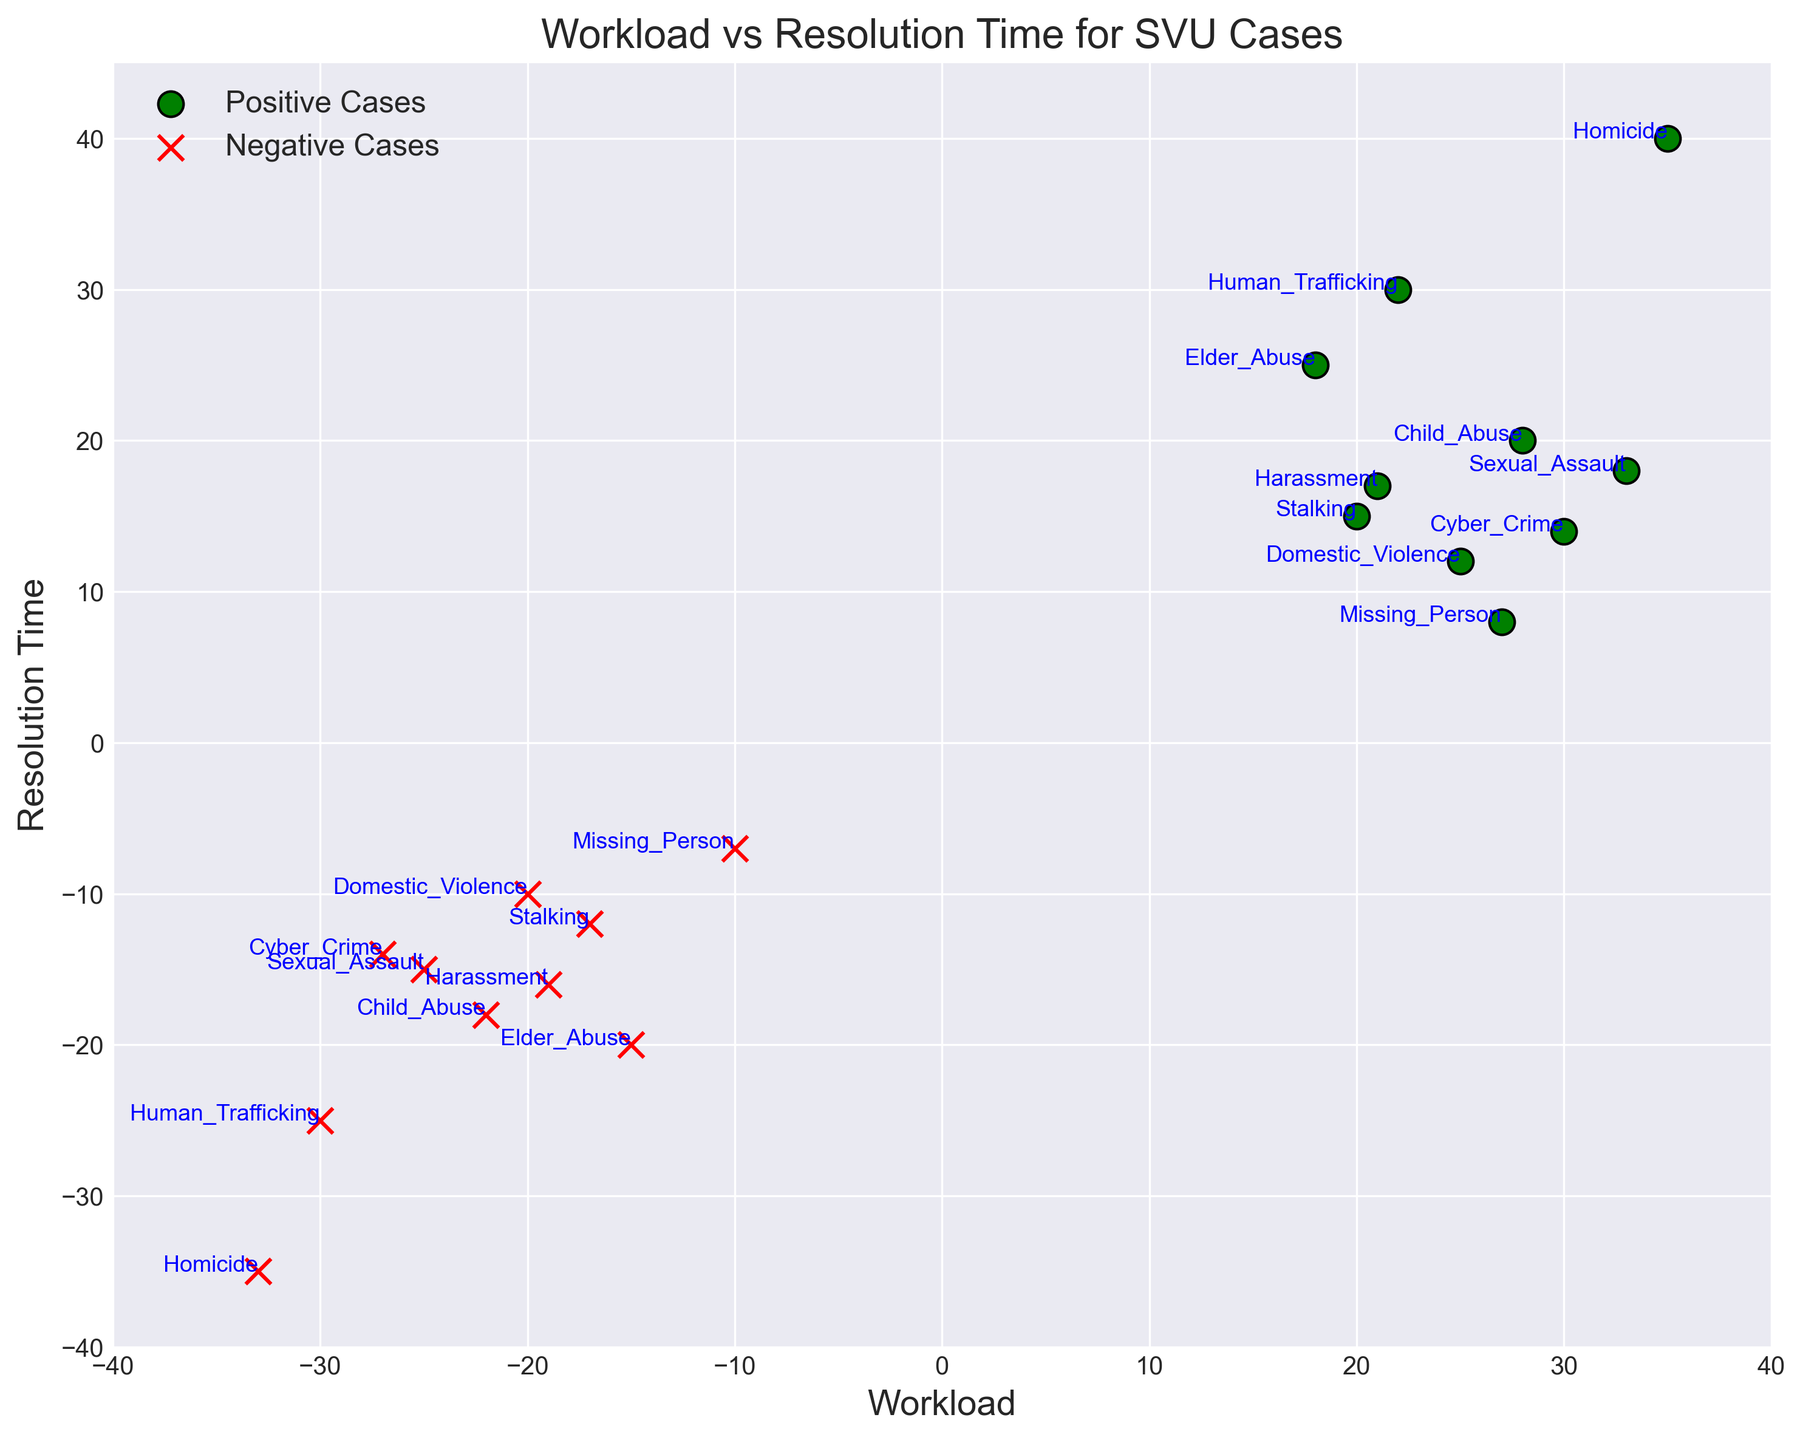Which case type has the highest workload for positive values? To find the case type with the highest workload on the positive scale, we look for the largest value on the x-axis among the green dots. This happens at the point (35, 40), which is labeled as Homicide.
Answer: Homicide Which case type has the lowest resolution time for negative values? We look at the red dots and identify the dot with the smallest y-value. The smallest y-value for negative cases is -35, which corresponds to Homicide.
Answer: Homicide How many case types have a workload above 30 for positive values? We count the green dots that are located to the right of the x-value 30. There are two such points: Sexual Assault (33, 18) and Homicide (35, 40).
Answer: 2 Compare the resolution times for Cyber Crime in positive and negative values. Which is higher? We find the points for Cyber Crime: (30, 14) for positive values and (-27, -14) for negative values. Comparing the y-values, 14 is higher than -14.
Answer: Positive What is the total workload for positive values of Domestic Violence and Sexual Assault? We sum the x-values for Domestic Violence (25) and Sexual Assault (33). 25 + 33 = 58.
Answer: 58 Which case type has a higher resolution time, Human Trafficking or Child Abuse for positive values? We compare the y-values for Human Trafficking (30) and Child Abuse (20) in the positive range. 30 is higher than 20.
Answer: Human Trafficking What is the average resolution time for the three case types with the highest workloads in positive values? We identify the case types with the highest workloads in positive values: Homicide (35, 40), Sexual Assault (33, 18), and Cyber Crime (30, 14). The resolution times are 40, 18, and 14 respectively. Their average is (40 + 18 + 14) / 3 = 24.
Answer: 24 Which has a lower resolution time, Elder Abuse or Harassment for negative values? For negative values, Elder Abuse is at (-15, -20) and Harassment is at (-19, -16). Comparing the y-values, -20 is lower than -16.
Answer: Elder Abuse Which case type has the greatest absolute difference in workload values between positive and negative scales? We compare the absolute differences between positive and negative workloads for each case type. Homicide with workloads 35 and -33 has the greatest difference, 35 - (-33) = 68.
Answer: Homicide 